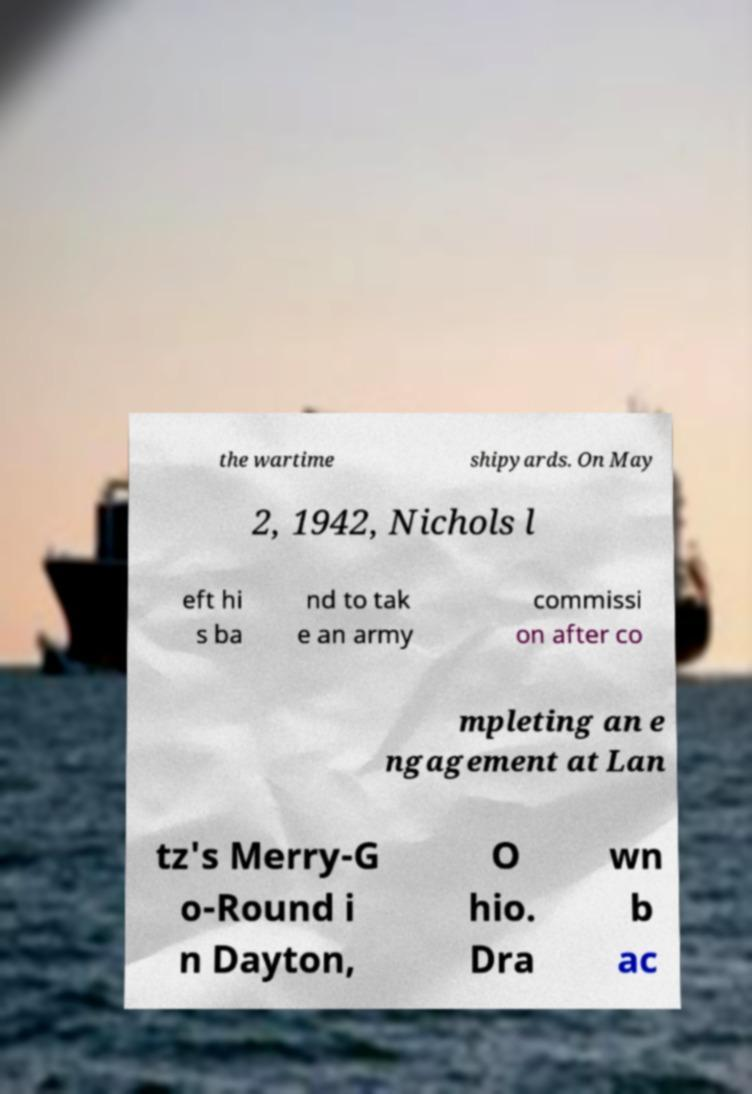Could you assist in decoding the text presented in this image and type it out clearly? the wartime shipyards. On May 2, 1942, Nichols l eft hi s ba nd to tak e an army commissi on after co mpleting an e ngagement at Lan tz's Merry-G o-Round i n Dayton, O hio. Dra wn b ac 